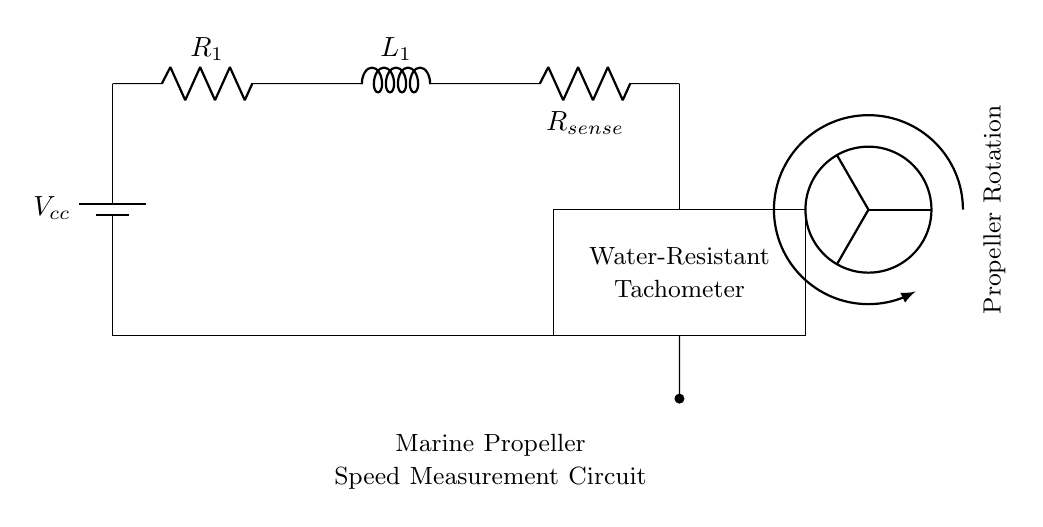What are the main components in this circuit? The main components are a battery, a resistor, an inductor, and a tachometer. These can be identified as they are labeled in the circuit diagram.
Answer: Battery, resistor, inductor, tachometer What type of circuit is this? This is an RL circuit, as it primarily consists of a resistor and an inductor connected in series. The function of this circuit is related to measuring rotational speed.
Answer: RL circuit What is the role of the sense resistor? The sense resistor is used for measuring current, which helps in determining the speed of the propeller by measuring the induced voltage across it due to the current flowing through it.
Answer: Measuring current What is connected to the output of the tachometer? The output of the tachometer is connected to the propeller, indicating that the circuit is measuring the rotational speed of the propeller directly.
Answer: Propeller How many resistors are in the circuit? There are two resistors present in the circuit: one labeled as R1 and the other as Rsense. These can be counted visually from the diagram.
Answer: Two resistors What does L1 represent in this circuit? L1 represents an inductor, which is crucial for the behavior of an RL circuit, playing a role in managing the current flow in response to changes in voltage over time.
Answer: Inductor What is the purpose of the battery in this circuit? The battery provides the necessary voltage to power the circuit, allowing the current to flow through the resistors and the inductor, which is essential for the operation of the tachometer.
Answer: Power supply 